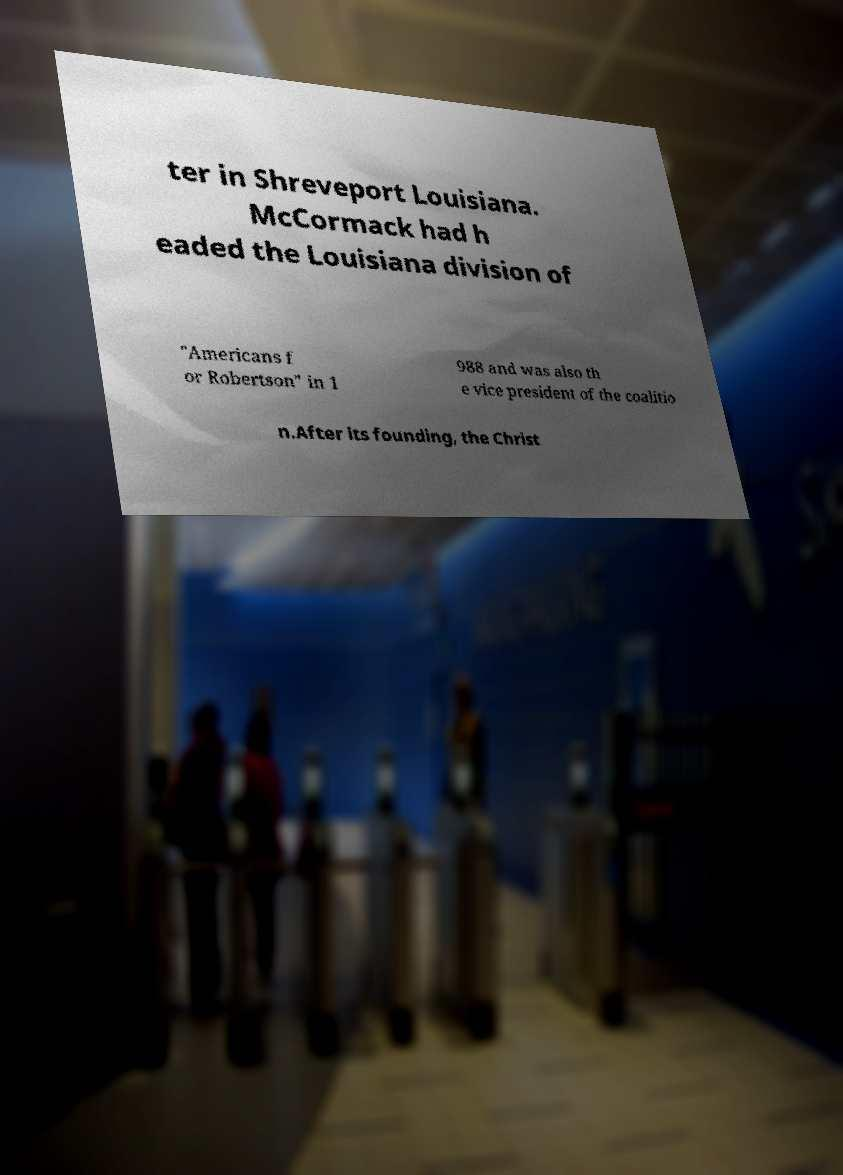Could you assist in decoding the text presented in this image and type it out clearly? ter in Shreveport Louisiana. McCormack had h eaded the Louisiana division of "Americans f or Robertson" in 1 988 and was also th e vice president of the coalitio n.After its founding, the Christ 